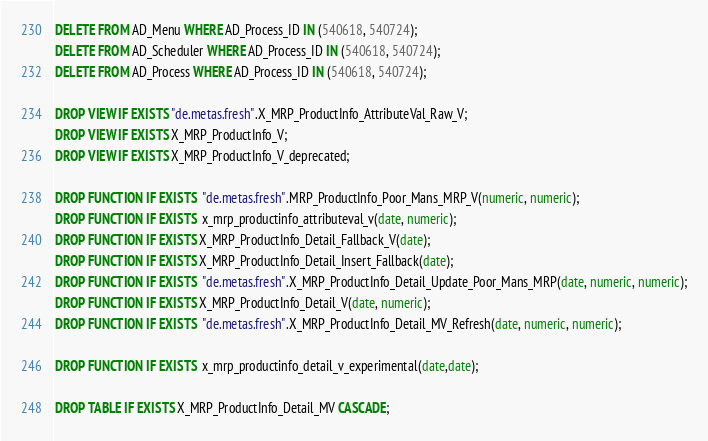<code> <loc_0><loc_0><loc_500><loc_500><_SQL_>
DELETE FROM AD_Menu WHERE AD_Process_ID IN (540618, 540724);
DELETE FROM AD_Scheduler WHERE AD_Process_ID IN (540618, 540724);
DELETE FROM AD_Process WHERE AD_Process_ID IN (540618, 540724);

DROP VIEW IF EXISTS "de.metas.fresh".X_MRP_ProductInfo_AttributeVal_Raw_V;
DROP VIEW IF EXISTS X_MRP_ProductInfo_V;
DROP VIEW IF EXISTS X_MRP_ProductInfo_V_deprecated;

DROP FUNCTION IF EXISTS  "de.metas.fresh".MRP_ProductInfo_Poor_Mans_MRP_V(numeric, numeric);
DROP FUNCTION IF EXISTS  x_mrp_productinfo_attributeval_v(date, numeric);
DROP FUNCTION IF EXISTS X_MRP_ProductInfo_Detail_Fallback_V(date);
DROP FUNCTION IF EXISTS X_MRP_ProductInfo_Detail_Insert_Fallback(date);
DROP FUNCTION IF EXISTS  "de.metas.fresh".X_MRP_ProductInfo_Detail_Update_Poor_Mans_MRP(date, numeric, numeric);
DROP FUNCTION IF EXISTS X_MRP_ProductInfo_Detail_V(date, numeric);
DROP FUNCTION IF EXISTS  "de.metas.fresh".X_MRP_ProductInfo_Detail_MV_Refresh(date, numeric, numeric);

DROP FUNCTION IF EXISTS  x_mrp_productinfo_detail_v_experimental(date,date);

DROP TABLE IF EXISTS X_MRP_ProductInfo_Detail_MV CASCADE;
</code> 